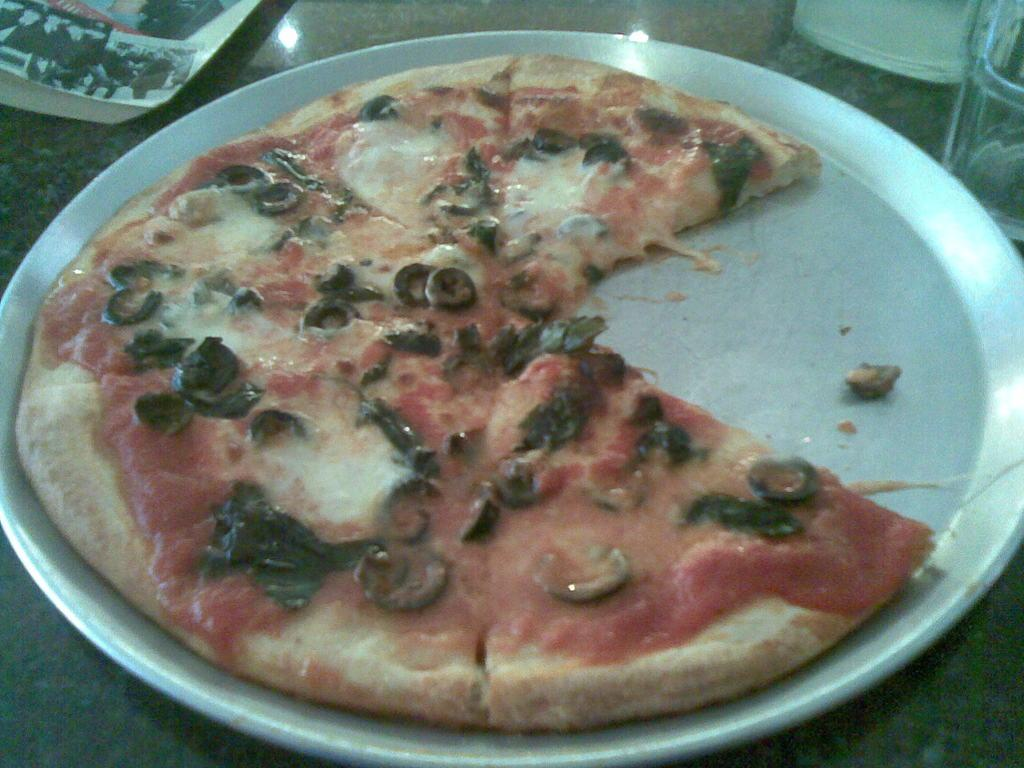What is on the plate that is visible in the image? The plate contains a pizza. What other items can be seen in the image besides the pizza? There is a book beside the plate and a glass on the right side top of the image. What type of rhythm can be heard from the mice in the image? There are no mice present in the image, so it is not possible to determine any rhythm. 